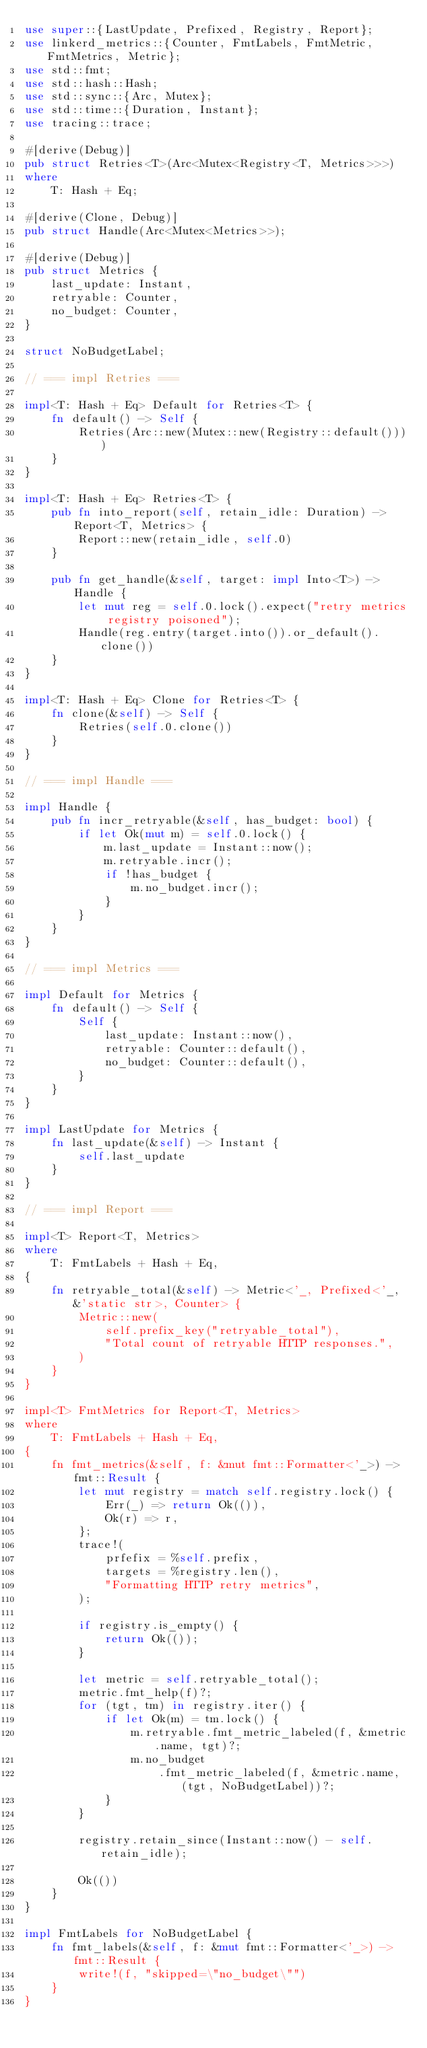Convert code to text. <code><loc_0><loc_0><loc_500><loc_500><_Rust_>use super::{LastUpdate, Prefixed, Registry, Report};
use linkerd_metrics::{Counter, FmtLabels, FmtMetric, FmtMetrics, Metric};
use std::fmt;
use std::hash::Hash;
use std::sync::{Arc, Mutex};
use std::time::{Duration, Instant};
use tracing::trace;

#[derive(Debug)]
pub struct Retries<T>(Arc<Mutex<Registry<T, Metrics>>>)
where
    T: Hash + Eq;

#[derive(Clone, Debug)]
pub struct Handle(Arc<Mutex<Metrics>>);

#[derive(Debug)]
pub struct Metrics {
    last_update: Instant,
    retryable: Counter,
    no_budget: Counter,
}

struct NoBudgetLabel;

// === impl Retries ===

impl<T: Hash + Eq> Default for Retries<T> {
    fn default() -> Self {
        Retries(Arc::new(Mutex::new(Registry::default())))
    }
}

impl<T: Hash + Eq> Retries<T> {
    pub fn into_report(self, retain_idle: Duration) -> Report<T, Metrics> {
        Report::new(retain_idle, self.0)
    }

    pub fn get_handle(&self, target: impl Into<T>) -> Handle {
        let mut reg = self.0.lock().expect("retry metrics registry poisoned");
        Handle(reg.entry(target.into()).or_default().clone())
    }
}

impl<T: Hash + Eq> Clone for Retries<T> {
    fn clone(&self) -> Self {
        Retries(self.0.clone())
    }
}

// === impl Handle ===

impl Handle {
    pub fn incr_retryable(&self, has_budget: bool) {
        if let Ok(mut m) = self.0.lock() {
            m.last_update = Instant::now();
            m.retryable.incr();
            if !has_budget {
                m.no_budget.incr();
            }
        }
    }
}

// === impl Metrics ===

impl Default for Metrics {
    fn default() -> Self {
        Self {
            last_update: Instant::now(),
            retryable: Counter::default(),
            no_budget: Counter::default(),
        }
    }
}

impl LastUpdate for Metrics {
    fn last_update(&self) -> Instant {
        self.last_update
    }
}

// === impl Report ===

impl<T> Report<T, Metrics>
where
    T: FmtLabels + Hash + Eq,
{
    fn retryable_total(&self) -> Metric<'_, Prefixed<'_, &'static str>, Counter> {
        Metric::new(
            self.prefix_key("retryable_total"),
            "Total count of retryable HTTP responses.",
        )
    }
}

impl<T> FmtMetrics for Report<T, Metrics>
where
    T: FmtLabels + Hash + Eq,
{
    fn fmt_metrics(&self, f: &mut fmt::Formatter<'_>) -> fmt::Result {
        let mut registry = match self.registry.lock() {
            Err(_) => return Ok(()),
            Ok(r) => r,
        };
        trace!(
            prfefix = %self.prefix,
            targets = %registry.len(),
            "Formatting HTTP retry metrics",
        );

        if registry.is_empty() {
            return Ok(());
        }

        let metric = self.retryable_total();
        metric.fmt_help(f)?;
        for (tgt, tm) in registry.iter() {
            if let Ok(m) = tm.lock() {
                m.retryable.fmt_metric_labeled(f, &metric.name, tgt)?;
                m.no_budget
                    .fmt_metric_labeled(f, &metric.name, (tgt, NoBudgetLabel))?;
            }
        }

        registry.retain_since(Instant::now() - self.retain_idle);

        Ok(())
    }
}

impl FmtLabels for NoBudgetLabel {
    fn fmt_labels(&self, f: &mut fmt::Formatter<'_>) -> fmt::Result {
        write!(f, "skipped=\"no_budget\"")
    }
}
</code> 